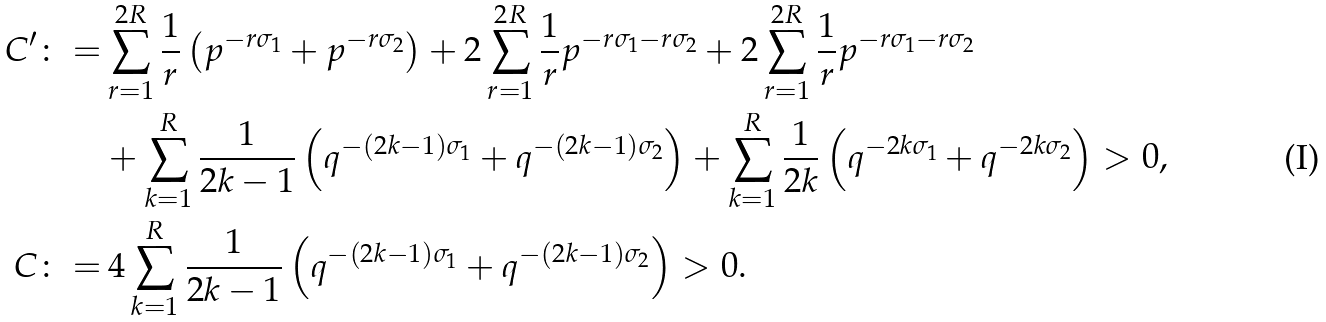Convert formula to latex. <formula><loc_0><loc_0><loc_500><loc_500>C ^ { \prime } \colon = & \sum _ { r = 1 } ^ { 2 R } \frac { 1 } { r } \left ( p ^ { - r \sigma _ { 1 } } + p ^ { - r \sigma _ { 2 } } \right ) + 2 \sum _ { r = 1 } ^ { 2 R } \frac { 1 } { r } p ^ { - r \sigma _ { 1 } - r \sigma _ { 2 } } + 2 \sum _ { r = 1 } ^ { 2 R } \frac { 1 } { r } p ^ { - r \sigma _ { 1 } - r \sigma _ { 2 } } \\ & + \sum _ { k = 1 } ^ { R } \frac { 1 } { 2 k - 1 } \left ( q ^ { - ( 2 k - 1 ) \sigma _ { 1 } } + q ^ { - ( 2 k - 1 ) \sigma _ { 2 } } \right ) + \sum _ { k = 1 } ^ { R } \frac { 1 } { 2 k } \left ( q ^ { - 2 k \sigma _ { 1 } } + q ^ { - 2 k \sigma _ { 2 } } \right ) > 0 , \\ C \colon = & \, 4 \sum _ { k = 1 } ^ { R } \frac { 1 } { 2 k - 1 } \left ( q ^ { - ( 2 k - 1 ) \sigma _ { 1 } } + q ^ { - ( 2 k - 1 ) \sigma _ { 2 } } \right ) > 0 .</formula> 